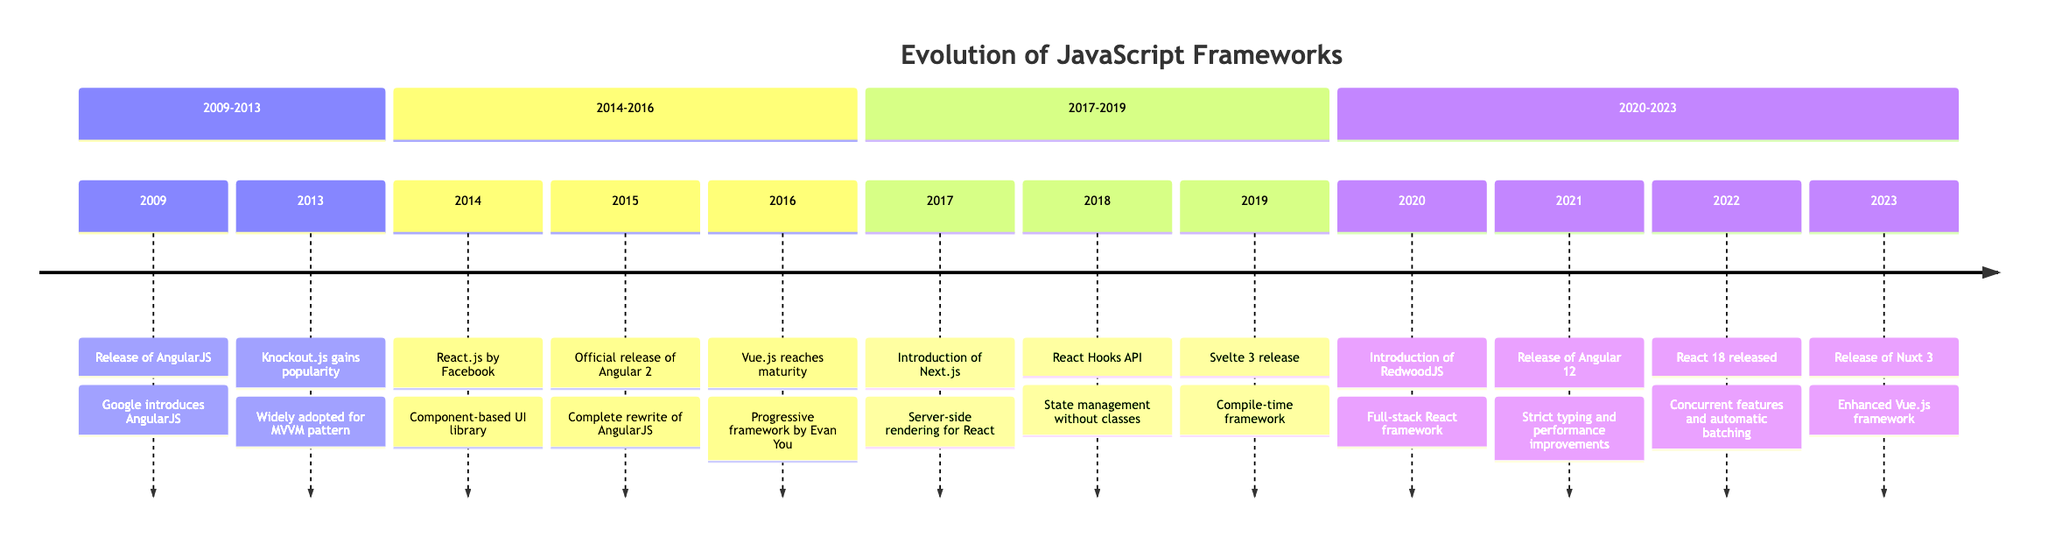What year was AngularJS released? The timeline shows the milestone "Release of AngularJS" in the year 2009, indicating the launch date of the framework.
Answer: 2009 Which framework was released in 2014? According to the timeline, the milestone for the year 2014 is "React.js by Facebook," which identifies the specific framework released that year.
Answer: React.js How many significant milestones are noted in 2016? By reviewing the timeline, there is one milestone for the year 2016: "Vue.js reaches maturity." Therefore, there is a total of one significant milestone for that year.
Answer: 1 Which framework introduced server-side rendering in 2017? The milestone "Introduction of Next.js" in the year 2017 specifies that this framework introduced server-side rendering capabilities.
Answer: Next.js What major version of Angular was released in 2021? The timeline indicates that Angular 12 was released in the year 2021. This is directly stated as the milestone for that year.
Answer: Angular 12 Which framework was released after React 18? Following the React 18 milestone in 2022, the next milestone in the timeline is "Release of Nuxt 3" in 2023. Therefore, Nuxt 3 was released afterward.
Answer: Nuxt 3 What significant update did React 18 introduce? The milestone for React 18 states that it included "concurrent features and automatic batching," indicating the key updates introduced in that version.
Answer: Concurrent features and automatic batching Which framework became widely adopted for the MVVM pattern? The timeline states that "Knockout.js gains popularity" in 2013, emphasizing its adoption for the MVVM (Model-View-ViewModel) pattern in web applications.
Answer: Knockout.js 